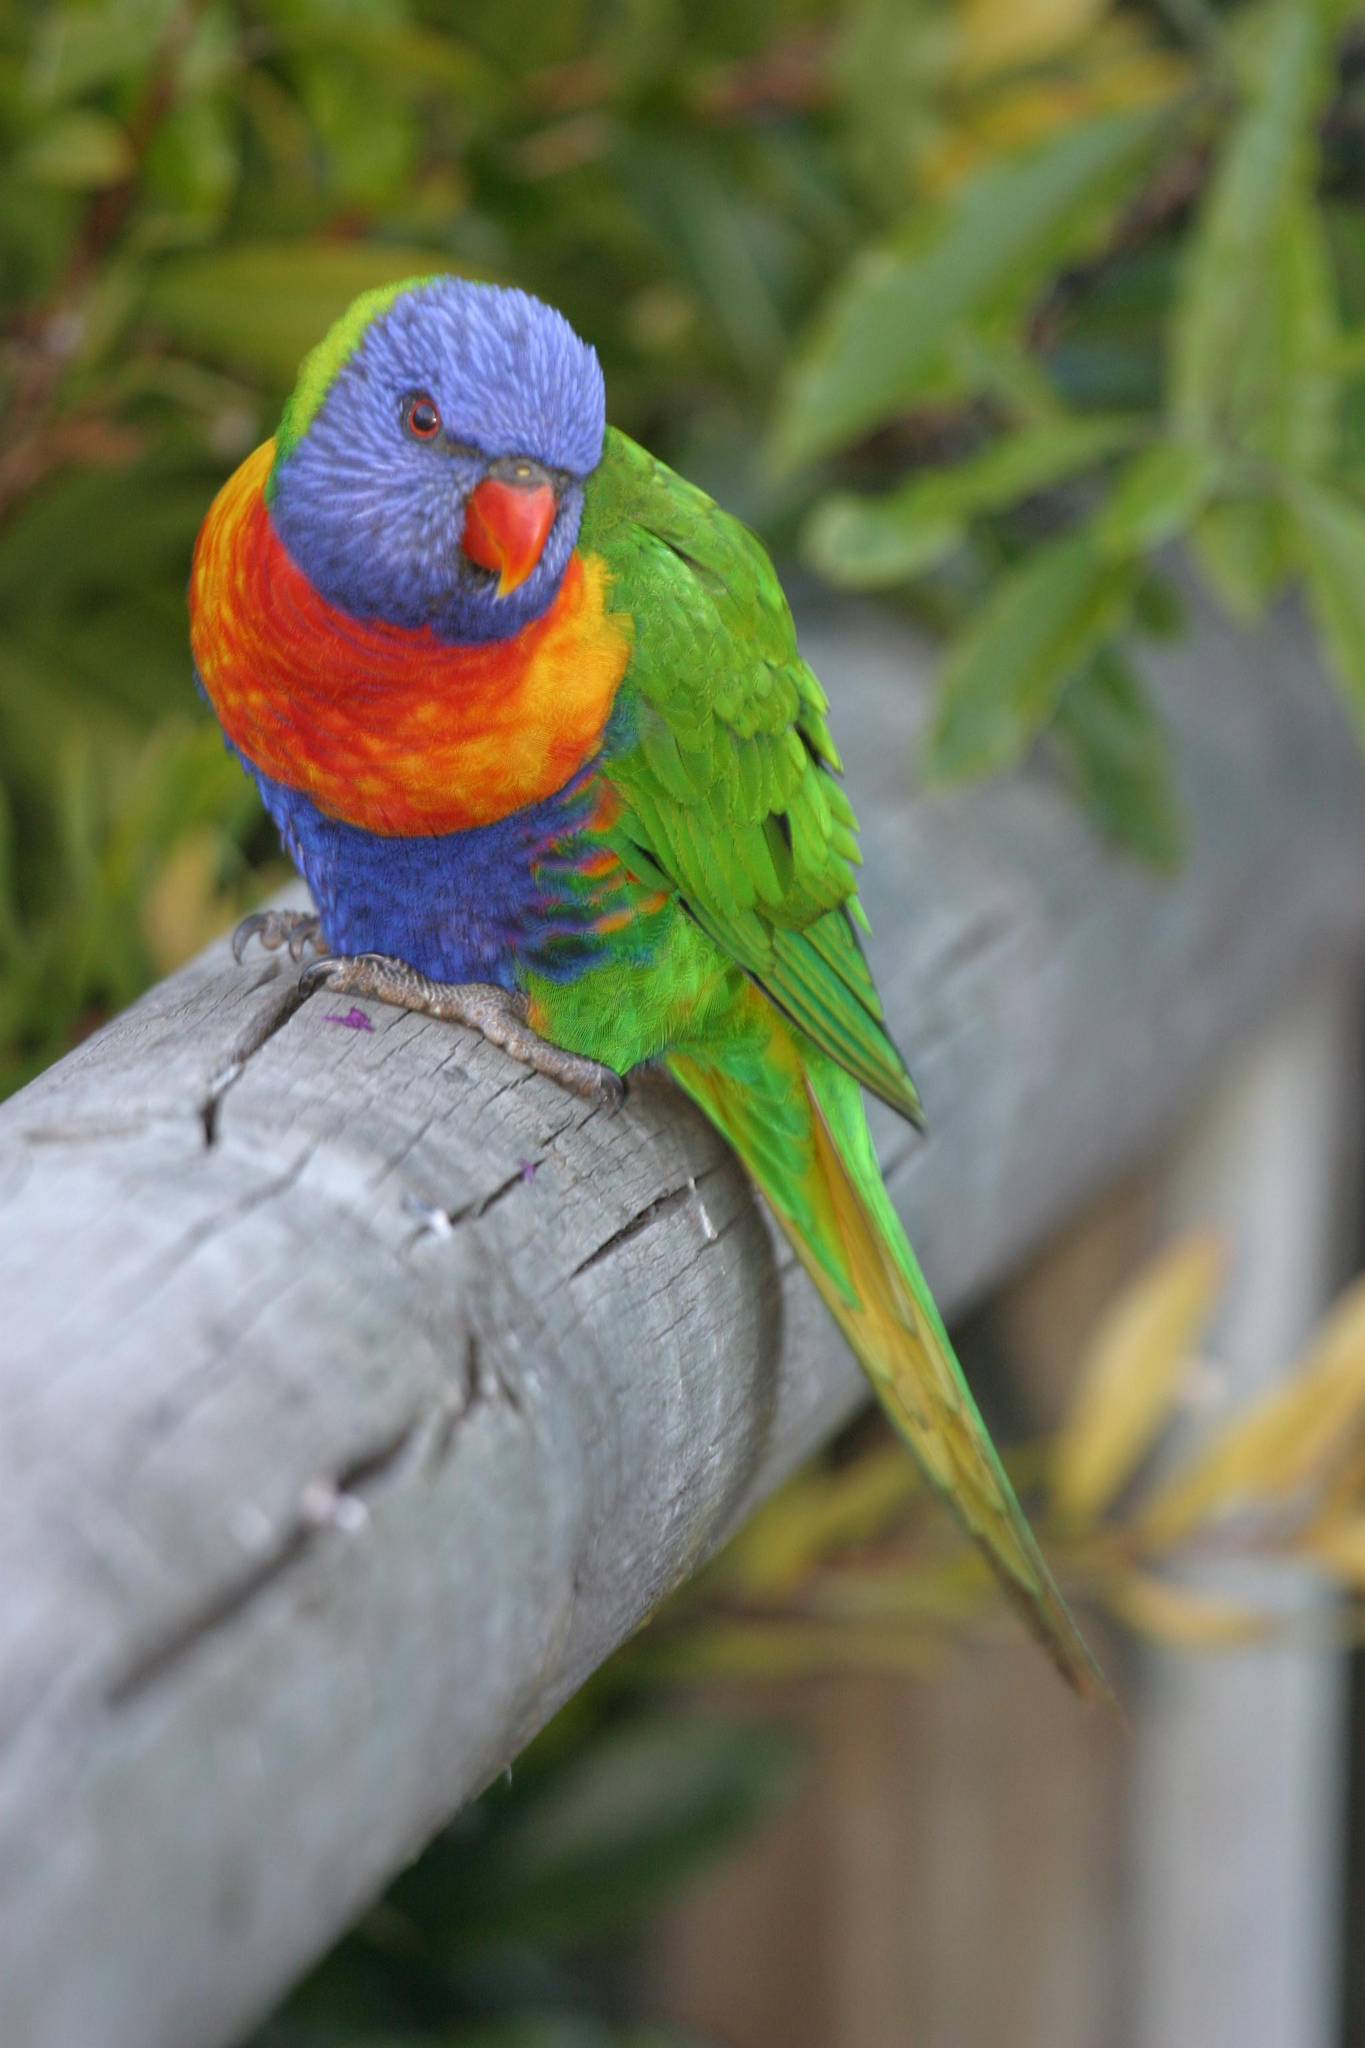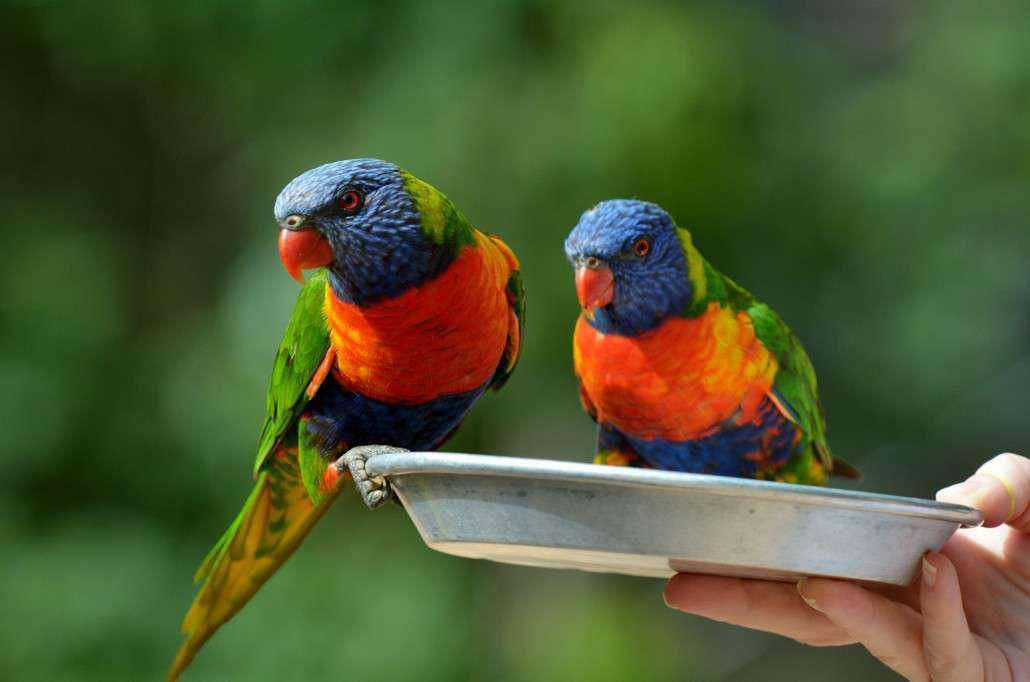The first image is the image on the left, the second image is the image on the right. Assess this claim about the two images: "Exactly three parrots are seated on perches.". Correct or not? Answer yes or no. Yes. 